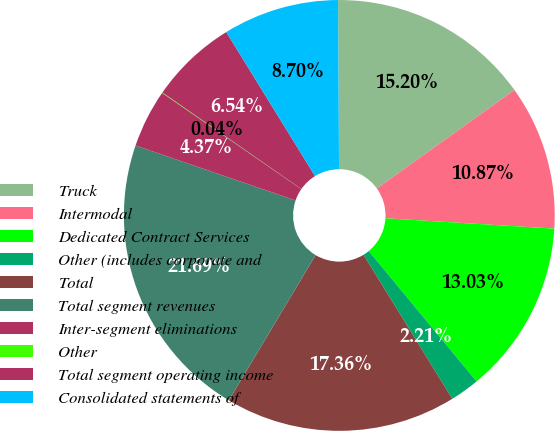Convert chart to OTSL. <chart><loc_0><loc_0><loc_500><loc_500><pie_chart><fcel>Truck<fcel>Intermodal<fcel>Dedicated Contract Services<fcel>Other (includes corporate and<fcel>Total<fcel>Total segment revenues<fcel>Inter-segment eliminations<fcel>Other<fcel>Total segment operating income<fcel>Consolidated statements of<nl><fcel>15.2%<fcel>10.87%<fcel>13.03%<fcel>2.21%<fcel>17.36%<fcel>21.69%<fcel>4.37%<fcel>0.04%<fcel>6.54%<fcel>8.7%<nl></chart> 